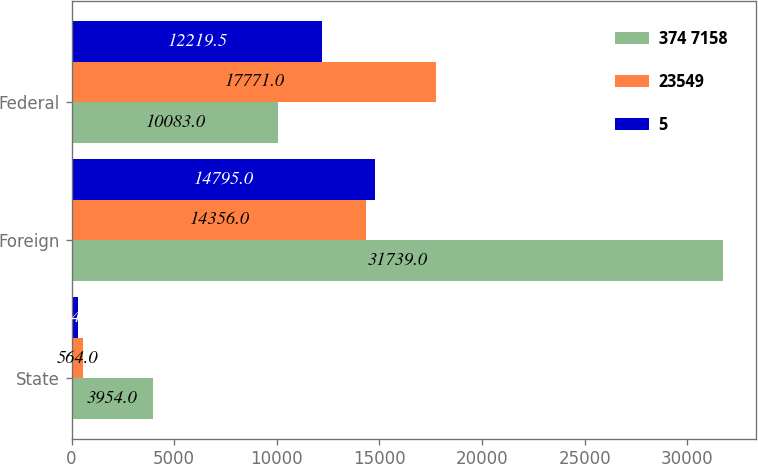Convert chart to OTSL. <chart><loc_0><loc_0><loc_500><loc_500><stacked_bar_chart><ecel><fcel>State<fcel>Foreign<fcel>Federal<nl><fcel>374 7158<fcel>3954<fcel>31739<fcel>10083<nl><fcel>23549<fcel>564<fcel>14356<fcel>17771<nl><fcel>5<fcel>304<fcel>14795<fcel>12219.5<nl></chart> 